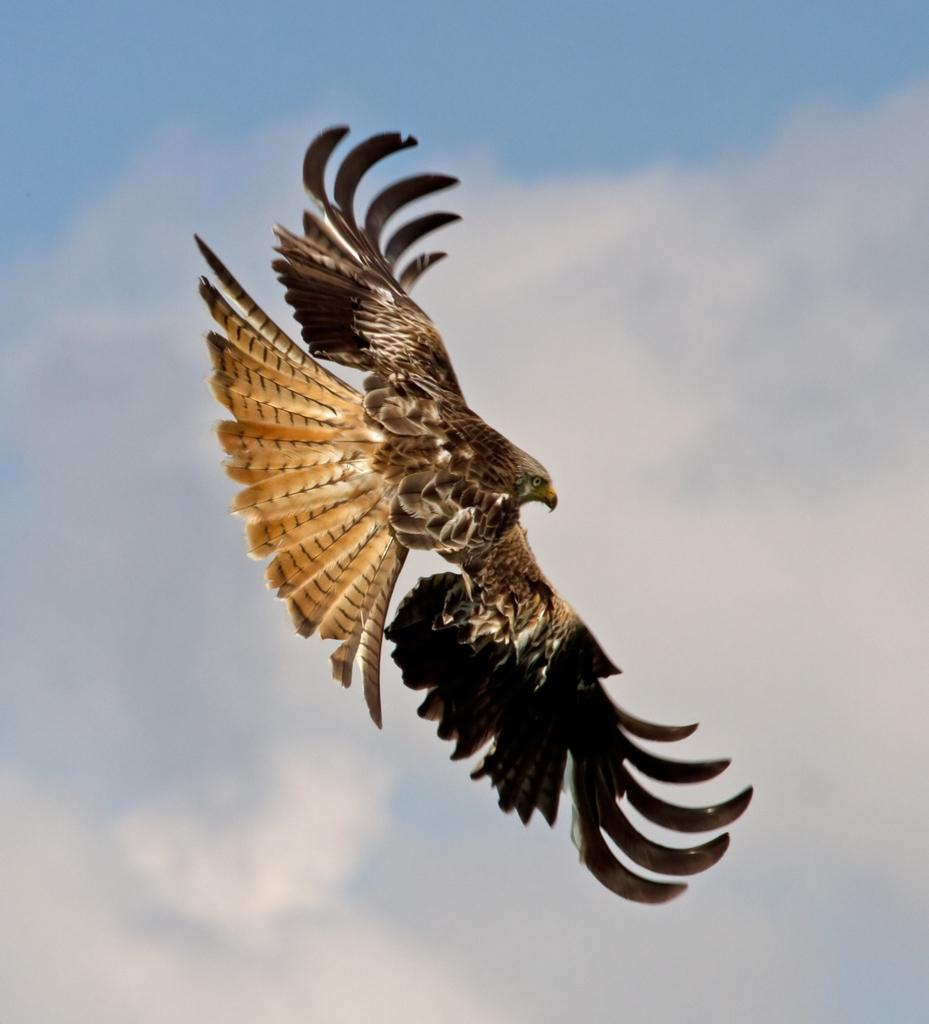What type of animal can be seen in the image? There is a bird in the image. What is the bird doing in the image? The bird is flying in the sky. What can be seen in the background of the image? Clouds are present in the sky in the background of the image. What type of dog is playing basketball in the image? There is no dog or basketball present in the image; it features a bird flying in the sky. 